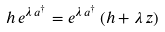<formula> <loc_0><loc_0><loc_500><loc_500>h \, e ^ { \lambda \, a ^ { \dagger } } = e ^ { \lambda \, a ^ { \dagger } } \, ( h + \lambda \, z )</formula> 